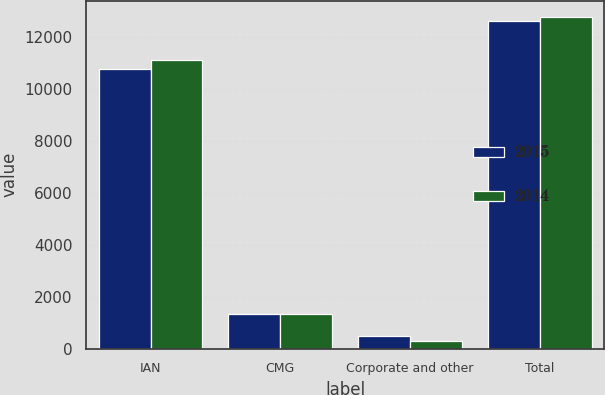<chart> <loc_0><loc_0><loc_500><loc_500><stacked_bar_chart><ecel><fcel>IAN<fcel>CMG<fcel>Corporate and other<fcel>Total<nl><fcel>2015<fcel>10738.2<fcel>1338.6<fcel>508.3<fcel>12585.1<nl><fcel>2014<fcel>11080.2<fcel>1347.5<fcel>308.9<fcel>12736.6<nl></chart> 